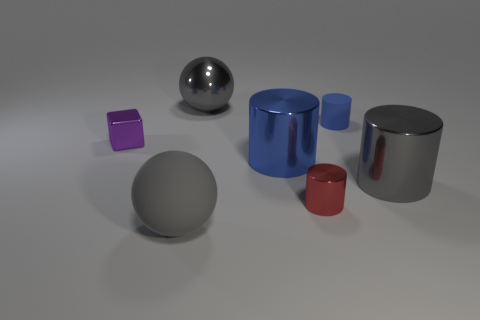Subtract 1 cylinders. How many cylinders are left? 3 Add 3 cylinders. How many objects exist? 10 Subtract all blocks. How many objects are left? 6 Subtract all tiny purple objects. Subtract all large green spheres. How many objects are left? 6 Add 4 large blue metallic things. How many large blue metallic things are left? 5 Add 5 big gray metal cylinders. How many big gray metal cylinders exist? 6 Subtract 1 gray cylinders. How many objects are left? 6 